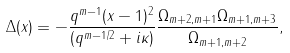<formula> <loc_0><loc_0><loc_500><loc_500>\Delta ( x ) = - \frac { q ^ { m - 1 } ( x - 1 ) ^ { 2 } } { ( q ^ { m - 1 / 2 } + i \kappa ) } \frac { \Omega _ { m + 2 , m + 1 } \Omega _ { m + 1 , m + 3 } } { \Omega _ { m + 1 , m + 2 } } ,</formula> 